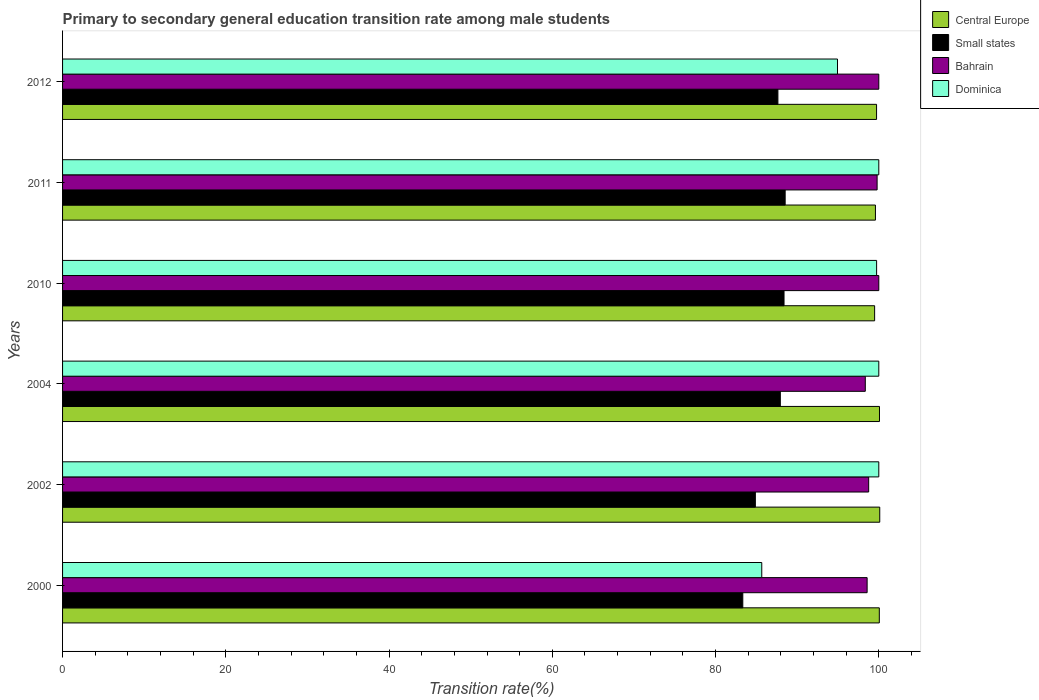How many different coloured bars are there?
Give a very brief answer. 4. How many groups of bars are there?
Your answer should be very brief. 6. Are the number of bars per tick equal to the number of legend labels?
Your answer should be compact. Yes. Are the number of bars on each tick of the Y-axis equal?
Give a very brief answer. Yes. How many bars are there on the 6th tick from the top?
Offer a very short reply. 4. In how many cases, is the number of bars for a given year not equal to the number of legend labels?
Ensure brevity in your answer.  0. What is the transition rate in Dominica in 2010?
Keep it short and to the point. 99.73. Across all years, what is the maximum transition rate in Dominica?
Your response must be concise. 100. Across all years, what is the minimum transition rate in Bahrain?
Give a very brief answer. 98.35. In which year was the transition rate in Dominica maximum?
Ensure brevity in your answer.  2002. In which year was the transition rate in Dominica minimum?
Provide a short and direct response. 2000. What is the total transition rate in Dominica in the graph?
Give a very brief answer. 580.34. What is the difference between the transition rate in Central Europe in 2004 and that in 2010?
Offer a terse response. 0.59. What is the difference between the transition rate in Dominica in 2010 and the transition rate in Bahrain in 2011?
Give a very brief answer. -0.06. What is the average transition rate in Dominica per year?
Make the answer very short. 96.72. In the year 2000, what is the difference between the transition rate in Central Europe and transition rate in Small states?
Offer a very short reply. 16.73. What is the ratio of the transition rate in Central Europe in 2010 to that in 2012?
Ensure brevity in your answer.  1. What is the difference between the highest and the second highest transition rate in Small states?
Make the answer very short. 0.14. What is the difference between the highest and the lowest transition rate in Small states?
Your response must be concise. 5.19. Is the sum of the transition rate in Small states in 2000 and 2004 greater than the maximum transition rate in Bahrain across all years?
Keep it short and to the point. Yes. What does the 2nd bar from the top in 2010 represents?
Offer a very short reply. Bahrain. What does the 3rd bar from the bottom in 2002 represents?
Your answer should be very brief. Bahrain. How many bars are there?
Offer a terse response. 24. What is the difference between two consecutive major ticks on the X-axis?
Provide a succinct answer. 20. Does the graph contain any zero values?
Offer a very short reply. No. Where does the legend appear in the graph?
Make the answer very short. Top right. What is the title of the graph?
Your answer should be compact. Primary to secondary general education transition rate among male students. What is the label or title of the X-axis?
Your response must be concise. Transition rate(%). What is the label or title of the Y-axis?
Offer a very short reply. Years. What is the Transition rate(%) of Central Europe in 2000?
Offer a terse response. 100.06. What is the Transition rate(%) of Small states in 2000?
Your answer should be very brief. 83.34. What is the Transition rate(%) of Bahrain in 2000?
Ensure brevity in your answer.  98.57. What is the Transition rate(%) of Dominica in 2000?
Your answer should be compact. 85.66. What is the Transition rate(%) of Central Europe in 2002?
Offer a very short reply. 100.12. What is the Transition rate(%) in Small states in 2002?
Your response must be concise. 84.88. What is the Transition rate(%) of Bahrain in 2002?
Your answer should be very brief. 98.76. What is the Transition rate(%) of Central Europe in 2004?
Provide a short and direct response. 100.08. What is the Transition rate(%) in Small states in 2004?
Provide a short and direct response. 87.94. What is the Transition rate(%) of Bahrain in 2004?
Provide a short and direct response. 98.35. What is the Transition rate(%) of Central Europe in 2010?
Provide a short and direct response. 99.49. What is the Transition rate(%) of Small states in 2010?
Your answer should be compact. 88.39. What is the Transition rate(%) of Bahrain in 2010?
Your response must be concise. 100. What is the Transition rate(%) in Dominica in 2010?
Provide a succinct answer. 99.73. What is the Transition rate(%) of Central Europe in 2011?
Offer a very short reply. 99.59. What is the Transition rate(%) of Small states in 2011?
Make the answer very short. 88.53. What is the Transition rate(%) in Bahrain in 2011?
Offer a terse response. 99.79. What is the Transition rate(%) of Dominica in 2011?
Offer a terse response. 100. What is the Transition rate(%) of Central Europe in 2012?
Give a very brief answer. 99.73. What is the Transition rate(%) in Small states in 2012?
Offer a very short reply. 87.64. What is the Transition rate(%) in Dominica in 2012?
Keep it short and to the point. 94.94. Across all years, what is the maximum Transition rate(%) in Central Europe?
Keep it short and to the point. 100.12. Across all years, what is the maximum Transition rate(%) of Small states?
Provide a short and direct response. 88.53. Across all years, what is the minimum Transition rate(%) in Central Europe?
Provide a short and direct response. 99.49. Across all years, what is the minimum Transition rate(%) in Small states?
Make the answer very short. 83.34. Across all years, what is the minimum Transition rate(%) in Bahrain?
Make the answer very short. 98.35. Across all years, what is the minimum Transition rate(%) of Dominica?
Provide a succinct answer. 85.66. What is the total Transition rate(%) in Central Europe in the graph?
Your answer should be compact. 599.07. What is the total Transition rate(%) of Small states in the graph?
Give a very brief answer. 520.71. What is the total Transition rate(%) of Bahrain in the graph?
Provide a short and direct response. 595.47. What is the total Transition rate(%) in Dominica in the graph?
Offer a very short reply. 580.34. What is the difference between the Transition rate(%) of Central Europe in 2000 and that in 2002?
Your answer should be compact. -0.05. What is the difference between the Transition rate(%) of Small states in 2000 and that in 2002?
Your answer should be compact. -1.54. What is the difference between the Transition rate(%) of Bahrain in 2000 and that in 2002?
Your answer should be compact. -0.19. What is the difference between the Transition rate(%) of Dominica in 2000 and that in 2002?
Provide a succinct answer. -14.34. What is the difference between the Transition rate(%) in Central Europe in 2000 and that in 2004?
Give a very brief answer. -0.02. What is the difference between the Transition rate(%) of Small states in 2000 and that in 2004?
Make the answer very short. -4.6. What is the difference between the Transition rate(%) of Bahrain in 2000 and that in 2004?
Make the answer very short. 0.22. What is the difference between the Transition rate(%) in Dominica in 2000 and that in 2004?
Give a very brief answer. -14.34. What is the difference between the Transition rate(%) of Central Europe in 2000 and that in 2010?
Provide a short and direct response. 0.57. What is the difference between the Transition rate(%) in Small states in 2000 and that in 2010?
Make the answer very short. -5.05. What is the difference between the Transition rate(%) in Bahrain in 2000 and that in 2010?
Offer a terse response. -1.43. What is the difference between the Transition rate(%) of Dominica in 2000 and that in 2010?
Offer a terse response. -14.07. What is the difference between the Transition rate(%) of Central Europe in 2000 and that in 2011?
Make the answer very short. 0.47. What is the difference between the Transition rate(%) of Small states in 2000 and that in 2011?
Your response must be concise. -5.19. What is the difference between the Transition rate(%) of Bahrain in 2000 and that in 2011?
Your answer should be very brief. -1.22. What is the difference between the Transition rate(%) in Dominica in 2000 and that in 2011?
Ensure brevity in your answer.  -14.34. What is the difference between the Transition rate(%) in Central Europe in 2000 and that in 2012?
Give a very brief answer. 0.34. What is the difference between the Transition rate(%) of Small states in 2000 and that in 2012?
Offer a very short reply. -4.3. What is the difference between the Transition rate(%) of Bahrain in 2000 and that in 2012?
Make the answer very short. -1.43. What is the difference between the Transition rate(%) of Dominica in 2000 and that in 2012?
Offer a terse response. -9.28. What is the difference between the Transition rate(%) of Central Europe in 2002 and that in 2004?
Offer a very short reply. 0.03. What is the difference between the Transition rate(%) in Small states in 2002 and that in 2004?
Offer a very short reply. -3.06. What is the difference between the Transition rate(%) of Bahrain in 2002 and that in 2004?
Keep it short and to the point. 0.41. What is the difference between the Transition rate(%) in Dominica in 2002 and that in 2004?
Your response must be concise. 0. What is the difference between the Transition rate(%) in Central Europe in 2002 and that in 2010?
Ensure brevity in your answer.  0.63. What is the difference between the Transition rate(%) of Small states in 2002 and that in 2010?
Offer a very short reply. -3.51. What is the difference between the Transition rate(%) of Bahrain in 2002 and that in 2010?
Give a very brief answer. -1.24. What is the difference between the Transition rate(%) in Dominica in 2002 and that in 2010?
Your answer should be very brief. 0.27. What is the difference between the Transition rate(%) of Central Europe in 2002 and that in 2011?
Offer a terse response. 0.53. What is the difference between the Transition rate(%) of Small states in 2002 and that in 2011?
Make the answer very short. -3.65. What is the difference between the Transition rate(%) in Bahrain in 2002 and that in 2011?
Your answer should be compact. -1.03. What is the difference between the Transition rate(%) in Dominica in 2002 and that in 2011?
Your answer should be very brief. 0. What is the difference between the Transition rate(%) in Central Europe in 2002 and that in 2012?
Offer a terse response. 0.39. What is the difference between the Transition rate(%) in Small states in 2002 and that in 2012?
Your response must be concise. -2.76. What is the difference between the Transition rate(%) of Bahrain in 2002 and that in 2012?
Make the answer very short. -1.24. What is the difference between the Transition rate(%) of Dominica in 2002 and that in 2012?
Your answer should be very brief. 5.06. What is the difference between the Transition rate(%) in Central Europe in 2004 and that in 2010?
Offer a very short reply. 0.59. What is the difference between the Transition rate(%) in Small states in 2004 and that in 2010?
Your answer should be compact. -0.45. What is the difference between the Transition rate(%) in Bahrain in 2004 and that in 2010?
Offer a terse response. -1.65. What is the difference between the Transition rate(%) in Dominica in 2004 and that in 2010?
Provide a short and direct response. 0.27. What is the difference between the Transition rate(%) in Central Europe in 2004 and that in 2011?
Your response must be concise. 0.5. What is the difference between the Transition rate(%) in Small states in 2004 and that in 2011?
Provide a short and direct response. -0.59. What is the difference between the Transition rate(%) of Bahrain in 2004 and that in 2011?
Your answer should be very brief. -1.45. What is the difference between the Transition rate(%) of Central Europe in 2004 and that in 2012?
Give a very brief answer. 0.36. What is the difference between the Transition rate(%) in Small states in 2004 and that in 2012?
Keep it short and to the point. 0.3. What is the difference between the Transition rate(%) in Bahrain in 2004 and that in 2012?
Provide a succinct answer. -1.65. What is the difference between the Transition rate(%) in Dominica in 2004 and that in 2012?
Make the answer very short. 5.06. What is the difference between the Transition rate(%) in Central Europe in 2010 and that in 2011?
Ensure brevity in your answer.  -0.1. What is the difference between the Transition rate(%) in Small states in 2010 and that in 2011?
Provide a short and direct response. -0.14. What is the difference between the Transition rate(%) of Bahrain in 2010 and that in 2011?
Make the answer very short. 0.21. What is the difference between the Transition rate(%) of Dominica in 2010 and that in 2011?
Give a very brief answer. -0.27. What is the difference between the Transition rate(%) in Central Europe in 2010 and that in 2012?
Provide a short and direct response. -0.24. What is the difference between the Transition rate(%) in Small states in 2010 and that in 2012?
Make the answer very short. 0.75. What is the difference between the Transition rate(%) of Dominica in 2010 and that in 2012?
Your answer should be very brief. 4.79. What is the difference between the Transition rate(%) of Central Europe in 2011 and that in 2012?
Offer a very short reply. -0.14. What is the difference between the Transition rate(%) of Small states in 2011 and that in 2012?
Your answer should be compact. 0.89. What is the difference between the Transition rate(%) in Bahrain in 2011 and that in 2012?
Provide a short and direct response. -0.21. What is the difference between the Transition rate(%) of Dominica in 2011 and that in 2012?
Your answer should be compact. 5.06. What is the difference between the Transition rate(%) of Central Europe in 2000 and the Transition rate(%) of Small states in 2002?
Provide a succinct answer. 15.19. What is the difference between the Transition rate(%) in Central Europe in 2000 and the Transition rate(%) in Bahrain in 2002?
Your response must be concise. 1.3. What is the difference between the Transition rate(%) in Central Europe in 2000 and the Transition rate(%) in Dominica in 2002?
Provide a succinct answer. 0.06. What is the difference between the Transition rate(%) of Small states in 2000 and the Transition rate(%) of Bahrain in 2002?
Your answer should be compact. -15.42. What is the difference between the Transition rate(%) of Small states in 2000 and the Transition rate(%) of Dominica in 2002?
Provide a short and direct response. -16.66. What is the difference between the Transition rate(%) of Bahrain in 2000 and the Transition rate(%) of Dominica in 2002?
Provide a succinct answer. -1.43. What is the difference between the Transition rate(%) of Central Europe in 2000 and the Transition rate(%) of Small states in 2004?
Your response must be concise. 12.13. What is the difference between the Transition rate(%) in Central Europe in 2000 and the Transition rate(%) in Bahrain in 2004?
Provide a short and direct response. 1.72. What is the difference between the Transition rate(%) in Central Europe in 2000 and the Transition rate(%) in Dominica in 2004?
Offer a very short reply. 0.06. What is the difference between the Transition rate(%) in Small states in 2000 and the Transition rate(%) in Bahrain in 2004?
Your answer should be very brief. -15.01. What is the difference between the Transition rate(%) of Small states in 2000 and the Transition rate(%) of Dominica in 2004?
Offer a very short reply. -16.66. What is the difference between the Transition rate(%) in Bahrain in 2000 and the Transition rate(%) in Dominica in 2004?
Make the answer very short. -1.43. What is the difference between the Transition rate(%) in Central Europe in 2000 and the Transition rate(%) in Small states in 2010?
Keep it short and to the point. 11.67. What is the difference between the Transition rate(%) of Central Europe in 2000 and the Transition rate(%) of Bahrain in 2010?
Your answer should be compact. 0.06. What is the difference between the Transition rate(%) in Central Europe in 2000 and the Transition rate(%) in Dominica in 2010?
Make the answer very short. 0.33. What is the difference between the Transition rate(%) in Small states in 2000 and the Transition rate(%) in Bahrain in 2010?
Make the answer very short. -16.66. What is the difference between the Transition rate(%) in Small states in 2000 and the Transition rate(%) in Dominica in 2010?
Your answer should be very brief. -16.4. What is the difference between the Transition rate(%) of Bahrain in 2000 and the Transition rate(%) of Dominica in 2010?
Give a very brief answer. -1.16. What is the difference between the Transition rate(%) of Central Europe in 2000 and the Transition rate(%) of Small states in 2011?
Provide a short and direct response. 11.54. What is the difference between the Transition rate(%) in Central Europe in 2000 and the Transition rate(%) in Bahrain in 2011?
Give a very brief answer. 0.27. What is the difference between the Transition rate(%) in Central Europe in 2000 and the Transition rate(%) in Dominica in 2011?
Provide a succinct answer. 0.06. What is the difference between the Transition rate(%) in Small states in 2000 and the Transition rate(%) in Bahrain in 2011?
Ensure brevity in your answer.  -16.46. What is the difference between the Transition rate(%) of Small states in 2000 and the Transition rate(%) of Dominica in 2011?
Ensure brevity in your answer.  -16.66. What is the difference between the Transition rate(%) in Bahrain in 2000 and the Transition rate(%) in Dominica in 2011?
Ensure brevity in your answer.  -1.43. What is the difference between the Transition rate(%) in Central Europe in 2000 and the Transition rate(%) in Small states in 2012?
Make the answer very short. 12.43. What is the difference between the Transition rate(%) in Central Europe in 2000 and the Transition rate(%) in Bahrain in 2012?
Your response must be concise. 0.06. What is the difference between the Transition rate(%) of Central Europe in 2000 and the Transition rate(%) of Dominica in 2012?
Your answer should be compact. 5.12. What is the difference between the Transition rate(%) of Small states in 2000 and the Transition rate(%) of Bahrain in 2012?
Keep it short and to the point. -16.66. What is the difference between the Transition rate(%) in Small states in 2000 and the Transition rate(%) in Dominica in 2012?
Offer a terse response. -11.6. What is the difference between the Transition rate(%) in Bahrain in 2000 and the Transition rate(%) in Dominica in 2012?
Keep it short and to the point. 3.63. What is the difference between the Transition rate(%) of Central Europe in 2002 and the Transition rate(%) of Small states in 2004?
Give a very brief answer. 12.18. What is the difference between the Transition rate(%) in Central Europe in 2002 and the Transition rate(%) in Bahrain in 2004?
Provide a short and direct response. 1.77. What is the difference between the Transition rate(%) in Central Europe in 2002 and the Transition rate(%) in Dominica in 2004?
Ensure brevity in your answer.  0.12. What is the difference between the Transition rate(%) of Small states in 2002 and the Transition rate(%) of Bahrain in 2004?
Offer a very short reply. -13.47. What is the difference between the Transition rate(%) in Small states in 2002 and the Transition rate(%) in Dominica in 2004?
Your answer should be compact. -15.12. What is the difference between the Transition rate(%) in Bahrain in 2002 and the Transition rate(%) in Dominica in 2004?
Provide a succinct answer. -1.24. What is the difference between the Transition rate(%) in Central Europe in 2002 and the Transition rate(%) in Small states in 2010?
Keep it short and to the point. 11.73. What is the difference between the Transition rate(%) in Central Europe in 2002 and the Transition rate(%) in Bahrain in 2010?
Provide a succinct answer. 0.12. What is the difference between the Transition rate(%) in Central Europe in 2002 and the Transition rate(%) in Dominica in 2010?
Give a very brief answer. 0.39. What is the difference between the Transition rate(%) in Small states in 2002 and the Transition rate(%) in Bahrain in 2010?
Your response must be concise. -15.12. What is the difference between the Transition rate(%) in Small states in 2002 and the Transition rate(%) in Dominica in 2010?
Make the answer very short. -14.85. What is the difference between the Transition rate(%) in Bahrain in 2002 and the Transition rate(%) in Dominica in 2010?
Your answer should be compact. -0.97. What is the difference between the Transition rate(%) of Central Europe in 2002 and the Transition rate(%) of Small states in 2011?
Your answer should be very brief. 11.59. What is the difference between the Transition rate(%) of Central Europe in 2002 and the Transition rate(%) of Bahrain in 2011?
Offer a very short reply. 0.32. What is the difference between the Transition rate(%) of Central Europe in 2002 and the Transition rate(%) of Dominica in 2011?
Offer a very short reply. 0.12. What is the difference between the Transition rate(%) of Small states in 2002 and the Transition rate(%) of Bahrain in 2011?
Give a very brief answer. -14.92. What is the difference between the Transition rate(%) in Small states in 2002 and the Transition rate(%) in Dominica in 2011?
Ensure brevity in your answer.  -15.12. What is the difference between the Transition rate(%) of Bahrain in 2002 and the Transition rate(%) of Dominica in 2011?
Keep it short and to the point. -1.24. What is the difference between the Transition rate(%) of Central Europe in 2002 and the Transition rate(%) of Small states in 2012?
Your answer should be very brief. 12.48. What is the difference between the Transition rate(%) in Central Europe in 2002 and the Transition rate(%) in Bahrain in 2012?
Your answer should be compact. 0.12. What is the difference between the Transition rate(%) of Central Europe in 2002 and the Transition rate(%) of Dominica in 2012?
Your answer should be very brief. 5.18. What is the difference between the Transition rate(%) of Small states in 2002 and the Transition rate(%) of Bahrain in 2012?
Offer a terse response. -15.12. What is the difference between the Transition rate(%) in Small states in 2002 and the Transition rate(%) in Dominica in 2012?
Provide a short and direct response. -10.06. What is the difference between the Transition rate(%) of Bahrain in 2002 and the Transition rate(%) of Dominica in 2012?
Give a very brief answer. 3.82. What is the difference between the Transition rate(%) in Central Europe in 2004 and the Transition rate(%) in Small states in 2010?
Your response must be concise. 11.69. What is the difference between the Transition rate(%) in Central Europe in 2004 and the Transition rate(%) in Bahrain in 2010?
Offer a terse response. 0.08. What is the difference between the Transition rate(%) in Central Europe in 2004 and the Transition rate(%) in Dominica in 2010?
Your answer should be very brief. 0.35. What is the difference between the Transition rate(%) in Small states in 2004 and the Transition rate(%) in Bahrain in 2010?
Give a very brief answer. -12.06. What is the difference between the Transition rate(%) of Small states in 2004 and the Transition rate(%) of Dominica in 2010?
Keep it short and to the point. -11.8. What is the difference between the Transition rate(%) of Bahrain in 2004 and the Transition rate(%) of Dominica in 2010?
Make the answer very short. -1.39. What is the difference between the Transition rate(%) of Central Europe in 2004 and the Transition rate(%) of Small states in 2011?
Provide a succinct answer. 11.56. What is the difference between the Transition rate(%) of Central Europe in 2004 and the Transition rate(%) of Bahrain in 2011?
Give a very brief answer. 0.29. What is the difference between the Transition rate(%) of Central Europe in 2004 and the Transition rate(%) of Dominica in 2011?
Ensure brevity in your answer.  0.08. What is the difference between the Transition rate(%) of Small states in 2004 and the Transition rate(%) of Bahrain in 2011?
Your response must be concise. -11.86. What is the difference between the Transition rate(%) in Small states in 2004 and the Transition rate(%) in Dominica in 2011?
Ensure brevity in your answer.  -12.06. What is the difference between the Transition rate(%) of Bahrain in 2004 and the Transition rate(%) of Dominica in 2011?
Ensure brevity in your answer.  -1.65. What is the difference between the Transition rate(%) of Central Europe in 2004 and the Transition rate(%) of Small states in 2012?
Provide a succinct answer. 12.45. What is the difference between the Transition rate(%) of Central Europe in 2004 and the Transition rate(%) of Bahrain in 2012?
Provide a succinct answer. 0.08. What is the difference between the Transition rate(%) in Central Europe in 2004 and the Transition rate(%) in Dominica in 2012?
Keep it short and to the point. 5.14. What is the difference between the Transition rate(%) in Small states in 2004 and the Transition rate(%) in Bahrain in 2012?
Ensure brevity in your answer.  -12.06. What is the difference between the Transition rate(%) in Small states in 2004 and the Transition rate(%) in Dominica in 2012?
Make the answer very short. -7. What is the difference between the Transition rate(%) in Bahrain in 2004 and the Transition rate(%) in Dominica in 2012?
Offer a terse response. 3.41. What is the difference between the Transition rate(%) of Central Europe in 2010 and the Transition rate(%) of Small states in 2011?
Offer a terse response. 10.96. What is the difference between the Transition rate(%) in Central Europe in 2010 and the Transition rate(%) in Bahrain in 2011?
Keep it short and to the point. -0.3. What is the difference between the Transition rate(%) in Central Europe in 2010 and the Transition rate(%) in Dominica in 2011?
Keep it short and to the point. -0.51. What is the difference between the Transition rate(%) in Small states in 2010 and the Transition rate(%) in Bahrain in 2011?
Provide a short and direct response. -11.4. What is the difference between the Transition rate(%) in Small states in 2010 and the Transition rate(%) in Dominica in 2011?
Ensure brevity in your answer.  -11.61. What is the difference between the Transition rate(%) in Central Europe in 2010 and the Transition rate(%) in Small states in 2012?
Your answer should be very brief. 11.85. What is the difference between the Transition rate(%) of Central Europe in 2010 and the Transition rate(%) of Bahrain in 2012?
Offer a very short reply. -0.51. What is the difference between the Transition rate(%) of Central Europe in 2010 and the Transition rate(%) of Dominica in 2012?
Make the answer very short. 4.55. What is the difference between the Transition rate(%) of Small states in 2010 and the Transition rate(%) of Bahrain in 2012?
Ensure brevity in your answer.  -11.61. What is the difference between the Transition rate(%) in Small states in 2010 and the Transition rate(%) in Dominica in 2012?
Make the answer very short. -6.55. What is the difference between the Transition rate(%) in Bahrain in 2010 and the Transition rate(%) in Dominica in 2012?
Keep it short and to the point. 5.06. What is the difference between the Transition rate(%) in Central Europe in 2011 and the Transition rate(%) in Small states in 2012?
Your response must be concise. 11.95. What is the difference between the Transition rate(%) in Central Europe in 2011 and the Transition rate(%) in Bahrain in 2012?
Provide a succinct answer. -0.41. What is the difference between the Transition rate(%) in Central Europe in 2011 and the Transition rate(%) in Dominica in 2012?
Your answer should be compact. 4.65. What is the difference between the Transition rate(%) in Small states in 2011 and the Transition rate(%) in Bahrain in 2012?
Ensure brevity in your answer.  -11.47. What is the difference between the Transition rate(%) in Small states in 2011 and the Transition rate(%) in Dominica in 2012?
Give a very brief answer. -6.41. What is the difference between the Transition rate(%) of Bahrain in 2011 and the Transition rate(%) of Dominica in 2012?
Your answer should be very brief. 4.85. What is the average Transition rate(%) in Central Europe per year?
Your answer should be compact. 99.85. What is the average Transition rate(%) in Small states per year?
Your response must be concise. 86.78. What is the average Transition rate(%) of Bahrain per year?
Your answer should be compact. 99.24. What is the average Transition rate(%) of Dominica per year?
Your response must be concise. 96.72. In the year 2000, what is the difference between the Transition rate(%) in Central Europe and Transition rate(%) in Small states?
Offer a terse response. 16.73. In the year 2000, what is the difference between the Transition rate(%) in Central Europe and Transition rate(%) in Bahrain?
Offer a very short reply. 1.49. In the year 2000, what is the difference between the Transition rate(%) of Central Europe and Transition rate(%) of Dominica?
Keep it short and to the point. 14.4. In the year 2000, what is the difference between the Transition rate(%) in Small states and Transition rate(%) in Bahrain?
Your answer should be compact. -15.23. In the year 2000, what is the difference between the Transition rate(%) in Small states and Transition rate(%) in Dominica?
Offer a terse response. -2.32. In the year 2000, what is the difference between the Transition rate(%) of Bahrain and Transition rate(%) of Dominica?
Provide a short and direct response. 12.91. In the year 2002, what is the difference between the Transition rate(%) of Central Europe and Transition rate(%) of Small states?
Give a very brief answer. 15.24. In the year 2002, what is the difference between the Transition rate(%) of Central Europe and Transition rate(%) of Bahrain?
Ensure brevity in your answer.  1.36. In the year 2002, what is the difference between the Transition rate(%) of Central Europe and Transition rate(%) of Dominica?
Offer a terse response. 0.12. In the year 2002, what is the difference between the Transition rate(%) in Small states and Transition rate(%) in Bahrain?
Give a very brief answer. -13.88. In the year 2002, what is the difference between the Transition rate(%) of Small states and Transition rate(%) of Dominica?
Your answer should be compact. -15.12. In the year 2002, what is the difference between the Transition rate(%) of Bahrain and Transition rate(%) of Dominica?
Offer a very short reply. -1.24. In the year 2004, what is the difference between the Transition rate(%) in Central Europe and Transition rate(%) in Small states?
Offer a very short reply. 12.15. In the year 2004, what is the difference between the Transition rate(%) of Central Europe and Transition rate(%) of Bahrain?
Provide a succinct answer. 1.74. In the year 2004, what is the difference between the Transition rate(%) of Central Europe and Transition rate(%) of Dominica?
Offer a very short reply. 0.08. In the year 2004, what is the difference between the Transition rate(%) in Small states and Transition rate(%) in Bahrain?
Provide a succinct answer. -10.41. In the year 2004, what is the difference between the Transition rate(%) in Small states and Transition rate(%) in Dominica?
Your answer should be compact. -12.06. In the year 2004, what is the difference between the Transition rate(%) of Bahrain and Transition rate(%) of Dominica?
Your answer should be compact. -1.65. In the year 2010, what is the difference between the Transition rate(%) in Central Europe and Transition rate(%) in Bahrain?
Keep it short and to the point. -0.51. In the year 2010, what is the difference between the Transition rate(%) in Central Europe and Transition rate(%) in Dominica?
Provide a succinct answer. -0.24. In the year 2010, what is the difference between the Transition rate(%) of Small states and Transition rate(%) of Bahrain?
Provide a short and direct response. -11.61. In the year 2010, what is the difference between the Transition rate(%) of Small states and Transition rate(%) of Dominica?
Your answer should be compact. -11.34. In the year 2010, what is the difference between the Transition rate(%) of Bahrain and Transition rate(%) of Dominica?
Your answer should be compact. 0.27. In the year 2011, what is the difference between the Transition rate(%) of Central Europe and Transition rate(%) of Small states?
Offer a very short reply. 11.06. In the year 2011, what is the difference between the Transition rate(%) of Central Europe and Transition rate(%) of Bahrain?
Offer a very short reply. -0.2. In the year 2011, what is the difference between the Transition rate(%) in Central Europe and Transition rate(%) in Dominica?
Ensure brevity in your answer.  -0.41. In the year 2011, what is the difference between the Transition rate(%) of Small states and Transition rate(%) of Bahrain?
Provide a short and direct response. -11.26. In the year 2011, what is the difference between the Transition rate(%) in Small states and Transition rate(%) in Dominica?
Make the answer very short. -11.47. In the year 2011, what is the difference between the Transition rate(%) in Bahrain and Transition rate(%) in Dominica?
Give a very brief answer. -0.21. In the year 2012, what is the difference between the Transition rate(%) in Central Europe and Transition rate(%) in Small states?
Keep it short and to the point. 12.09. In the year 2012, what is the difference between the Transition rate(%) of Central Europe and Transition rate(%) of Bahrain?
Provide a succinct answer. -0.27. In the year 2012, what is the difference between the Transition rate(%) of Central Europe and Transition rate(%) of Dominica?
Keep it short and to the point. 4.79. In the year 2012, what is the difference between the Transition rate(%) of Small states and Transition rate(%) of Bahrain?
Make the answer very short. -12.36. In the year 2012, what is the difference between the Transition rate(%) in Small states and Transition rate(%) in Dominica?
Provide a short and direct response. -7.3. In the year 2012, what is the difference between the Transition rate(%) in Bahrain and Transition rate(%) in Dominica?
Provide a short and direct response. 5.06. What is the ratio of the Transition rate(%) in Central Europe in 2000 to that in 2002?
Keep it short and to the point. 1. What is the ratio of the Transition rate(%) of Small states in 2000 to that in 2002?
Your answer should be compact. 0.98. What is the ratio of the Transition rate(%) in Dominica in 2000 to that in 2002?
Give a very brief answer. 0.86. What is the ratio of the Transition rate(%) of Central Europe in 2000 to that in 2004?
Your answer should be very brief. 1. What is the ratio of the Transition rate(%) in Small states in 2000 to that in 2004?
Your answer should be very brief. 0.95. What is the ratio of the Transition rate(%) of Dominica in 2000 to that in 2004?
Offer a terse response. 0.86. What is the ratio of the Transition rate(%) of Small states in 2000 to that in 2010?
Your answer should be compact. 0.94. What is the ratio of the Transition rate(%) in Bahrain in 2000 to that in 2010?
Your answer should be very brief. 0.99. What is the ratio of the Transition rate(%) in Dominica in 2000 to that in 2010?
Your answer should be very brief. 0.86. What is the ratio of the Transition rate(%) of Central Europe in 2000 to that in 2011?
Offer a terse response. 1. What is the ratio of the Transition rate(%) in Small states in 2000 to that in 2011?
Offer a terse response. 0.94. What is the ratio of the Transition rate(%) in Dominica in 2000 to that in 2011?
Give a very brief answer. 0.86. What is the ratio of the Transition rate(%) of Central Europe in 2000 to that in 2012?
Provide a short and direct response. 1. What is the ratio of the Transition rate(%) in Small states in 2000 to that in 2012?
Offer a terse response. 0.95. What is the ratio of the Transition rate(%) in Bahrain in 2000 to that in 2012?
Make the answer very short. 0.99. What is the ratio of the Transition rate(%) of Dominica in 2000 to that in 2012?
Offer a terse response. 0.9. What is the ratio of the Transition rate(%) of Central Europe in 2002 to that in 2004?
Ensure brevity in your answer.  1. What is the ratio of the Transition rate(%) of Small states in 2002 to that in 2004?
Provide a short and direct response. 0.97. What is the ratio of the Transition rate(%) in Bahrain in 2002 to that in 2004?
Provide a short and direct response. 1. What is the ratio of the Transition rate(%) in Small states in 2002 to that in 2010?
Ensure brevity in your answer.  0.96. What is the ratio of the Transition rate(%) of Bahrain in 2002 to that in 2010?
Ensure brevity in your answer.  0.99. What is the ratio of the Transition rate(%) of Dominica in 2002 to that in 2010?
Provide a succinct answer. 1. What is the ratio of the Transition rate(%) of Central Europe in 2002 to that in 2011?
Ensure brevity in your answer.  1.01. What is the ratio of the Transition rate(%) of Small states in 2002 to that in 2011?
Your answer should be compact. 0.96. What is the ratio of the Transition rate(%) in Small states in 2002 to that in 2012?
Provide a short and direct response. 0.97. What is the ratio of the Transition rate(%) in Bahrain in 2002 to that in 2012?
Your answer should be very brief. 0.99. What is the ratio of the Transition rate(%) of Dominica in 2002 to that in 2012?
Provide a short and direct response. 1.05. What is the ratio of the Transition rate(%) of Central Europe in 2004 to that in 2010?
Provide a short and direct response. 1.01. What is the ratio of the Transition rate(%) in Small states in 2004 to that in 2010?
Your answer should be very brief. 0.99. What is the ratio of the Transition rate(%) in Bahrain in 2004 to that in 2010?
Offer a terse response. 0.98. What is the ratio of the Transition rate(%) of Dominica in 2004 to that in 2010?
Provide a short and direct response. 1. What is the ratio of the Transition rate(%) in Central Europe in 2004 to that in 2011?
Make the answer very short. 1. What is the ratio of the Transition rate(%) in Bahrain in 2004 to that in 2011?
Keep it short and to the point. 0.99. What is the ratio of the Transition rate(%) in Bahrain in 2004 to that in 2012?
Your response must be concise. 0.98. What is the ratio of the Transition rate(%) in Dominica in 2004 to that in 2012?
Your response must be concise. 1.05. What is the ratio of the Transition rate(%) in Central Europe in 2010 to that in 2011?
Your answer should be very brief. 1. What is the ratio of the Transition rate(%) in Small states in 2010 to that in 2011?
Keep it short and to the point. 1. What is the ratio of the Transition rate(%) of Central Europe in 2010 to that in 2012?
Provide a short and direct response. 1. What is the ratio of the Transition rate(%) of Small states in 2010 to that in 2012?
Provide a succinct answer. 1.01. What is the ratio of the Transition rate(%) of Bahrain in 2010 to that in 2012?
Make the answer very short. 1. What is the ratio of the Transition rate(%) in Dominica in 2010 to that in 2012?
Offer a terse response. 1.05. What is the ratio of the Transition rate(%) in Central Europe in 2011 to that in 2012?
Your answer should be very brief. 1. What is the ratio of the Transition rate(%) in Small states in 2011 to that in 2012?
Keep it short and to the point. 1.01. What is the ratio of the Transition rate(%) of Dominica in 2011 to that in 2012?
Provide a short and direct response. 1.05. What is the difference between the highest and the second highest Transition rate(%) in Central Europe?
Ensure brevity in your answer.  0.03. What is the difference between the highest and the second highest Transition rate(%) of Small states?
Provide a succinct answer. 0.14. What is the difference between the highest and the second highest Transition rate(%) of Bahrain?
Ensure brevity in your answer.  0. What is the difference between the highest and the lowest Transition rate(%) of Central Europe?
Your answer should be very brief. 0.63. What is the difference between the highest and the lowest Transition rate(%) of Small states?
Ensure brevity in your answer.  5.19. What is the difference between the highest and the lowest Transition rate(%) of Bahrain?
Provide a short and direct response. 1.65. What is the difference between the highest and the lowest Transition rate(%) of Dominica?
Your answer should be compact. 14.34. 